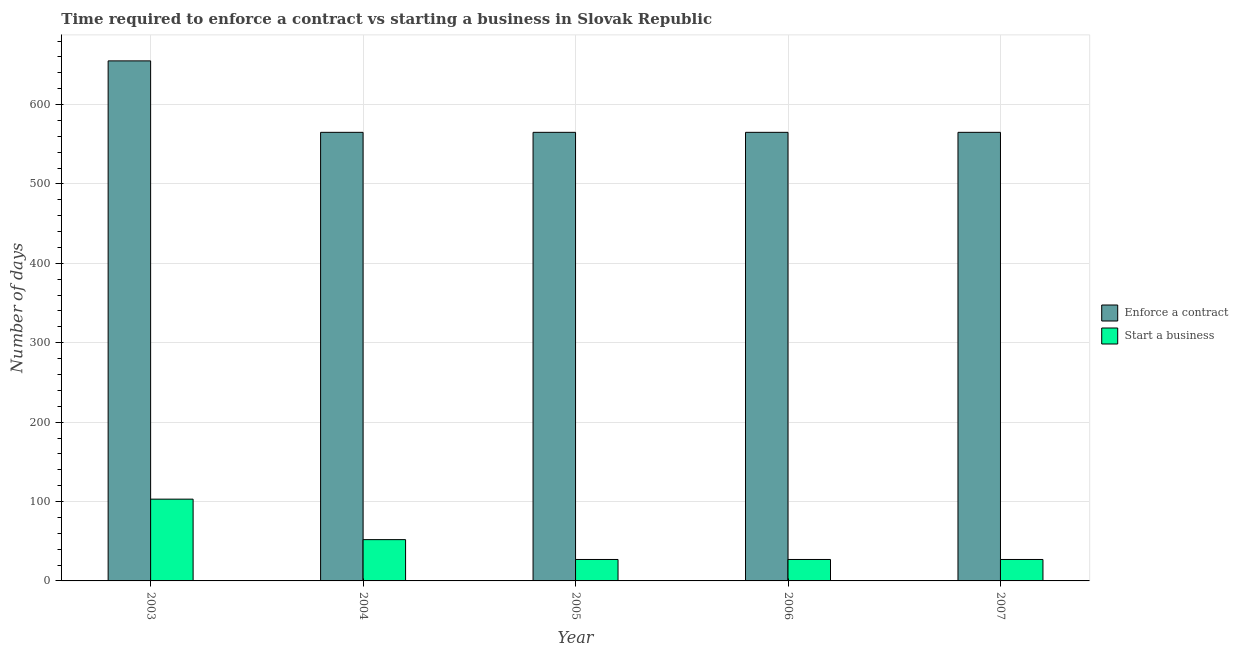Are the number of bars per tick equal to the number of legend labels?
Ensure brevity in your answer.  Yes. Are the number of bars on each tick of the X-axis equal?
Give a very brief answer. Yes. How many bars are there on the 3rd tick from the left?
Provide a succinct answer. 2. How many bars are there on the 3rd tick from the right?
Ensure brevity in your answer.  2. What is the label of the 4th group of bars from the left?
Offer a terse response. 2006. What is the number of days to enforece a contract in 2007?
Keep it short and to the point. 565. Across all years, what is the maximum number of days to enforece a contract?
Ensure brevity in your answer.  655. Across all years, what is the minimum number of days to enforece a contract?
Provide a short and direct response. 565. In which year was the number of days to start a business maximum?
Keep it short and to the point. 2003. What is the total number of days to enforece a contract in the graph?
Provide a succinct answer. 2915. What is the difference between the number of days to enforece a contract in 2004 and that in 2005?
Your answer should be very brief. 0. What is the difference between the number of days to enforece a contract in 2006 and the number of days to start a business in 2003?
Give a very brief answer. -90. What is the average number of days to enforece a contract per year?
Offer a very short reply. 583. In the year 2006, what is the difference between the number of days to start a business and number of days to enforece a contract?
Provide a succinct answer. 0. In how many years, is the number of days to start a business greater than 300 days?
Offer a terse response. 0. What is the ratio of the number of days to start a business in 2003 to that in 2007?
Provide a succinct answer. 3.81. What is the difference between the highest and the lowest number of days to enforece a contract?
Ensure brevity in your answer.  90. What does the 1st bar from the left in 2006 represents?
Ensure brevity in your answer.  Enforce a contract. What does the 1st bar from the right in 2007 represents?
Provide a short and direct response. Start a business. How many bars are there?
Give a very brief answer. 10. Are all the bars in the graph horizontal?
Your answer should be very brief. No. How many years are there in the graph?
Offer a terse response. 5. What is the difference between two consecutive major ticks on the Y-axis?
Give a very brief answer. 100. Does the graph contain any zero values?
Your response must be concise. No. How many legend labels are there?
Keep it short and to the point. 2. How are the legend labels stacked?
Your answer should be very brief. Vertical. What is the title of the graph?
Your answer should be very brief. Time required to enforce a contract vs starting a business in Slovak Republic. What is the label or title of the X-axis?
Your answer should be very brief. Year. What is the label or title of the Y-axis?
Make the answer very short. Number of days. What is the Number of days in Enforce a contract in 2003?
Provide a succinct answer. 655. What is the Number of days in Start a business in 2003?
Provide a succinct answer. 103. What is the Number of days of Enforce a contract in 2004?
Give a very brief answer. 565. What is the Number of days of Start a business in 2004?
Ensure brevity in your answer.  52. What is the Number of days of Enforce a contract in 2005?
Make the answer very short. 565. What is the Number of days of Enforce a contract in 2006?
Provide a short and direct response. 565. What is the Number of days of Start a business in 2006?
Your answer should be compact. 27. What is the Number of days in Enforce a contract in 2007?
Give a very brief answer. 565. What is the Number of days in Start a business in 2007?
Provide a succinct answer. 27. Across all years, what is the maximum Number of days of Enforce a contract?
Ensure brevity in your answer.  655. Across all years, what is the maximum Number of days in Start a business?
Give a very brief answer. 103. Across all years, what is the minimum Number of days of Enforce a contract?
Keep it short and to the point. 565. What is the total Number of days in Enforce a contract in the graph?
Offer a terse response. 2915. What is the total Number of days of Start a business in the graph?
Provide a succinct answer. 236. What is the difference between the Number of days in Start a business in 2003 and that in 2004?
Keep it short and to the point. 51. What is the difference between the Number of days of Enforce a contract in 2003 and that in 2006?
Your response must be concise. 90. What is the difference between the Number of days of Start a business in 2003 and that in 2007?
Offer a terse response. 76. What is the difference between the Number of days of Enforce a contract in 2004 and that in 2005?
Your answer should be compact. 0. What is the difference between the Number of days in Enforce a contract in 2004 and that in 2006?
Your answer should be very brief. 0. What is the difference between the Number of days in Start a business in 2004 and that in 2006?
Make the answer very short. 25. What is the difference between the Number of days in Enforce a contract in 2004 and that in 2007?
Offer a very short reply. 0. What is the difference between the Number of days in Enforce a contract in 2005 and that in 2006?
Ensure brevity in your answer.  0. What is the difference between the Number of days of Enforce a contract in 2003 and the Number of days of Start a business in 2004?
Your response must be concise. 603. What is the difference between the Number of days in Enforce a contract in 2003 and the Number of days in Start a business in 2005?
Your response must be concise. 628. What is the difference between the Number of days of Enforce a contract in 2003 and the Number of days of Start a business in 2006?
Your answer should be compact. 628. What is the difference between the Number of days of Enforce a contract in 2003 and the Number of days of Start a business in 2007?
Offer a terse response. 628. What is the difference between the Number of days of Enforce a contract in 2004 and the Number of days of Start a business in 2005?
Provide a succinct answer. 538. What is the difference between the Number of days in Enforce a contract in 2004 and the Number of days in Start a business in 2006?
Give a very brief answer. 538. What is the difference between the Number of days of Enforce a contract in 2004 and the Number of days of Start a business in 2007?
Your answer should be very brief. 538. What is the difference between the Number of days of Enforce a contract in 2005 and the Number of days of Start a business in 2006?
Provide a succinct answer. 538. What is the difference between the Number of days in Enforce a contract in 2005 and the Number of days in Start a business in 2007?
Offer a very short reply. 538. What is the difference between the Number of days of Enforce a contract in 2006 and the Number of days of Start a business in 2007?
Provide a short and direct response. 538. What is the average Number of days in Enforce a contract per year?
Make the answer very short. 583. What is the average Number of days in Start a business per year?
Your response must be concise. 47.2. In the year 2003, what is the difference between the Number of days of Enforce a contract and Number of days of Start a business?
Make the answer very short. 552. In the year 2004, what is the difference between the Number of days of Enforce a contract and Number of days of Start a business?
Your answer should be compact. 513. In the year 2005, what is the difference between the Number of days of Enforce a contract and Number of days of Start a business?
Offer a very short reply. 538. In the year 2006, what is the difference between the Number of days of Enforce a contract and Number of days of Start a business?
Your response must be concise. 538. In the year 2007, what is the difference between the Number of days of Enforce a contract and Number of days of Start a business?
Provide a succinct answer. 538. What is the ratio of the Number of days in Enforce a contract in 2003 to that in 2004?
Ensure brevity in your answer.  1.16. What is the ratio of the Number of days of Start a business in 2003 to that in 2004?
Provide a short and direct response. 1.98. What is the ratio of the Number of days in Enforce a contract in 2003 to that in 2005?
Provide a short and direct response. 1.16. What is the ratio of the Number of days of Start a business in 2003 to that in 2005?
Give a very brief answer. 3.81. What is the ratio of the Number of days of Enforce a contract in 2003 to that in 2006?
Offer a terse response. 1.16. What is the ratio of the Number of days of Start a business in 2003 to that in 2006?
Offer a terse response. 3.81. What is the ratio of the Number of days of Enforce a contract in 2003 to that in 2007?
Provide a short and direct response. 1.16. What is the ratio of the Number of days in Start a business in 2003 to that in 2007?
Ensure brevity in your answer.  3.81. What is the ratio of the Number of days of Start a business in 2004 to that in 2005?
Offer a very short reply. 1.93. What is the ratio of the Number of days in Enforce a contract in 2004 to that in 2006?
Offer a very short reply. 1. What is the ratio of the Number of days in Start a business in 2004 to that in 2006?
Give a very brief answer. 1.93. What is the ratio of the Number of days in Start a business in 2004 to that in 2007?
Make the answer very short. 1.93. What is the ratio of the Number of days of Enforce a contract in 2005 to that in 2006?
Your answer should be compact. 1. What is the ratio of the Number of days in Enforce a contract in 2005 to that in 2007?
Provide a succinct answer. 1. What is the ratio of the Number of days in Start a business in 2005 to that in 2007?
Your answer should be compact. 1. What is the ratio of the Number of days in Enforce a contract in 2006 to that in 2007?
Your response must be concise. 1. What is the ratio of the Number of days in Start a business in 2006 to that in 2007?
Your response must be concise. 1. What is the difference between the highest and the lowest Number of days of Enforce a contract?
Keep it short and to the point. 90. 